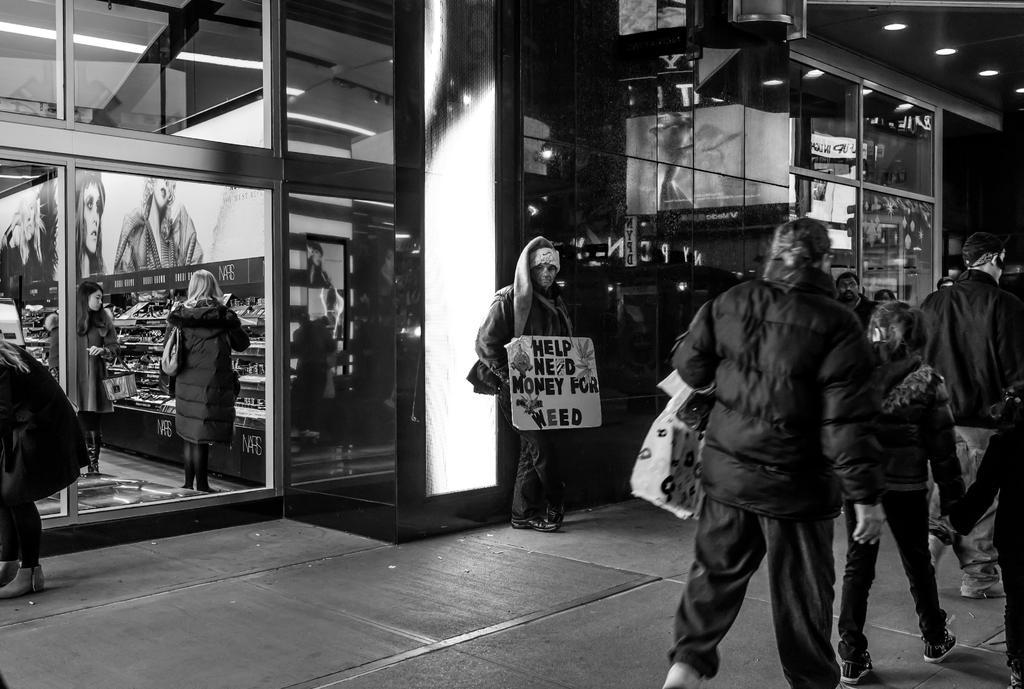How would you summarize this image in a sentence or two? There are few persons standing in the right corner and there is another person standing and holding a board which has something written on it beside them and there is a store behind him. 